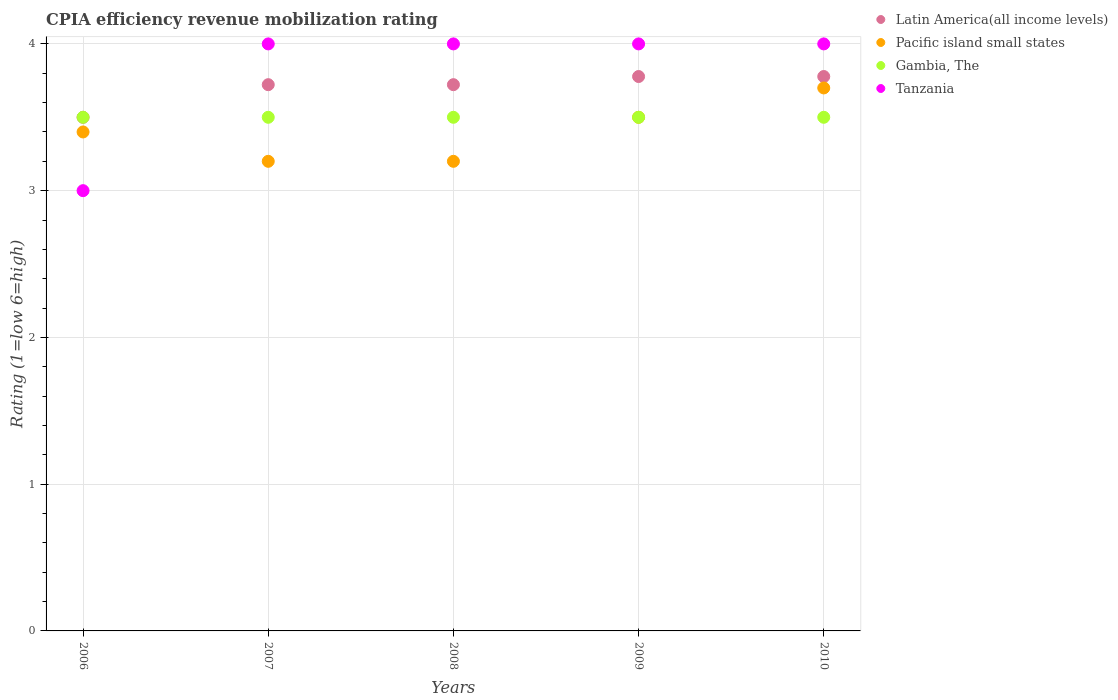How many different coloured dotlines are there?
Your response must be concise. 4. What is the total CPIA rating in Latin America(all income levels) in the graph?
Provide a short and direct response. 18.5. What is the difference between the CPIA rating in Pacific island small states in 2006 and that in 2007?
Your response must be concise. 0.2. What is the average CPIA rating in Pacific island small states per year?
Offer a terse response. 3.4. In the year 2008, what is the difference between the CPIA rating in Tanzania and CPIA rating in Pacific island small states?
Provide a short and direct response. 0.8. What is the ratio of the CPIA rating in Tanzania in 2006 to that in 2007?
Your response must be concise. 0.75. Is the CPIA rating in Gambia, The in 2006 less than that in 2009?
Provide a short and direct response. No. Is the difference between the CPIA rating in Tanzania in 2006 and 2009 greater than the difference between the CPIA rating in Pacific island small states in 2006 and 2009?
Your response must be concise. No. What is the difference between the highest and the second highest CPIA rating in Latin America(all income levels)?
Your response must be concise. 0. What is the difference between the highest and the lowest CPIA rating in Latin America(all income levels)?
Provide a short and direct response. 0.28. Is the sum of the CPIA rating in Latin America(all income levels) in 2008 and 2010 greater than the maximum CPIA rating in Gambia, The across all years?
Your answer should be very brief. Yes. Is it the case that in every year, the sum of the CPIA rating in Pacific island small states and CPIA rating in Latin America(all income levels)  is greater than the sum of CPIA rating in Gambia, The and CPIA rating in Tanzania?
Your answer should be compact. No. Is it the case that in every year, the sum of the CPIA rating in Pacific island small states and CPIA rating in Latin America(all income levels)  is greater than the CPIA rating in Tanzania?
Offer a terse response. Yes. Does the CPIA rating in Tanzania monotonically increase over the years?
Keep it short and to the point. No. Is the CPIA rating in Gambia, The strictly greater than the CPIA rating in Latin America(all income levels) over the years?
Provide a succinct answer. No. What is the difference between two consecutive major ticks on the Y-axis?
Ensure brevity in your answer.  1. Does the graph contain any zero values?
Offer a very short reply. No. Does the graph contain grids?
Your response must be concise. Yes. Where does the legend appear in the graph?
Ensure brevity in your answer.  Top right. How many legend labels are there?
Provide a short and direct response. 4. How are the legend labels stacked?
Provide a short and direct response. Vertical. What is the title of the graph?
Offer a terse response. CPIA efficiency revenue mobilization rating. Does "Jamaica" appear as one of the legend labels in the graph?
Keep it short and to the point. No. What is the label or title of the X-axis?
Your response must be concise. Years. What is the label or title of the Y-axis?
Keep it short and to the point. Rating (1=low 6=high). What is the Rating (1=low 6=high) of Latin America(all income levels) in 2006?
Make the answer very short. 3.5. What is the Rating (1=low 6=high) of Gambia, The in 2006?
Keep it short and to the point. 3.5. What is the Rating (1=low 6=high) in Latin America(all income levels) in 2007?
Offer a very short reply. 3.72. What is the Rating (1=low 6=high) of Pacific island small states in 2007?
Keep it short and to the point. 3.2. What is the Rating (1=low 6=high) of Tanzania in 2007?
Your answer should be very brief. 4. What is the Rating (1=low 6=high) in Latin America(all income levels) in 2008?
Keep it short and to the point. 3.72. What is the Rating (1=low 6=high) of Gambia, The in 2008?
Make the answer very short. 3.5. What is the Rating (1=low 6=high) of Tanzania in 2008?
Give a very brief answer. 4. What is the Rating (1=low 6=high) in Latin America(all income levels) in 2009?
Make the answer very short. 3.78. What is the Rating (1=low 6=high) of Pacific island small states in 2009?
Offer a very short reply. 3.5. What is the Rating (1=low 6=high) in Gambia, The in 2009?
Your response must be concise. 3.5. What is the Rating (1=low 6=high) of Latin America(all income levels) in 2010?
Provide a short and direct response. 3.78. What is the Rating (1=low 6=high) of Pacific island small states in 2010?
Offer a very short reply. 3.7. Across all years, what is the maximum Rating (1=low 6=high) in Latin America(all income levels)?
Provide a short and direct response. 3.78. Across all years, what is the maximum Rating (1=low 6=high) of Gambia, The?
Your answer should be very brief. 3.5. Across all years, what is the minimum Rating (1=low 6=high) in Latin America(all income levels)?
Provide a short and direct response. 3.5. What is the total Rating (1=low 6=high) in Pacific island small states in the graph?
Ensure brevity in your answer.  17. What is the total Rating (1=low 6=high) in Gambia, The in the graph?
Your response must be concise. 17.5. What is the difference between the Rating (1=low 6=high) in Latin America(all income levels) in 2006 and that in 2007?
Give a very brief answer. -0.22. What is the difference between the Rating (1=low 6=high) of Gambia, The in 2006 and that in 2007?
Offer a terse response. 0. What is the difference between the Rating (1=low 6=high) in Tanzania in 2006 and that in 2007?
Your answer should be compact. -1. What is the difference between the Rating (1=low 6=high) of Latin America(all income levels) in 2006 and that in 2008?
Ensure brevity in your answer.  -0.22. What is the difference between the Rating (1=low 6=high) of Pacific island small states in 2006 and that in 2008?
Keep it short and to the point. 0.2. What is the difference between the Rating (1=low 6=high) in Tanzania in 2006 and that in 2008?
Your response must be concise. -1. What is the difference between the Rating (1=low 6=high) in Latin America(all income levels) in 2006 and that in 2009?
Give a very brief answer. -0.28. What is the difference between the Rating (1=low 6=high) of Pacific island small states in 2006 and that in 2009?
Ensure brevity in your answer.  -0.1. What is the difference between the Rating (1=low 6=high) in Gambia, The in 2006 and that in 2009?
Keep it short and to the point. 0. What is the difference between the Rating (1=low 6=high) of Latin America(all income levels) in 2006 and that in 2010?
Your answer should be compact. -0.28. What is the difference between the Rating (1=low 6=high) of Latin America(all income levels) in 2007 and that in 2008?
Give a very brief answer. 0. What is the difference between the Rating (1=low 6=high) of Tanzania in 2007 and that in 2008?
Give a very brief answer. 0. What is the difference between the Rating (1=low 6=high) of Latin America(all income levels) in 2007 and that in 2009?
Make the answer very short. -0.06. What is the difference between the Rating (1=low 6=high) in Pacific island small states in 2007 and that in 2009?
Ensure brevity in your answer.  -0.3. What is the difference between the Rating (1=low 6=high) in Tanzania in 2007 and that in 2009?
Make the answer very short. 0. What is the difference between the Rating (1=low 6=high) of Latin America(all income levels) in 2007 and that in 2010?
Give a very brief answer. -0.06. What is the difference between the Rating (1=low 6=high) of Pacific island small states in 2007 and that in 2010?
Give a very brief answer. -0.5. What is the difference between the Rating (1=low 6=high) of Gambia, The in 2007 and that in 2010?
Offer a very short reply. 0. What is the difference between the Rating (1=low 6=high) in Latin America(all income levels) in 2008 and that in 2009?
Offer a terse response. -0.06. What is the difference between the Rating (1=low 6=high) in Gambia, The in 2008 and that in 2009?
Your answer should be very brief. 0. What is the difference between the Rating (1=low 6=high) in Tanzania in 2008 and that in 2009?
Ensure brevity in your answer.  0. What is the difference between the Rating (1=low 6=high) in Latin America(all income levels) in 2008 and that in 2010?
Keep it short and to the point. -0.06. What is the difference between the Rating (1=low 6=high) in Pacific island small states in 2008 and that in 2010?
Provide a short and direct response. -0.5. What is the difference between the Rating (1=low 6=high) of Latin America(all income levels) in 2009 and that in 2010?
Provide a short and direct response. 0. What is the difference between the Rating (1=low 6=high) of Pacific island small states in 2009 and that in 2010?
Ensure brevity in your answer.  -0.2. What is the difference between the Rating (1=low 6=high) of Gambia, The in 2009 and that in 2010?
Your answer should be very brief. 0. What is the difference between the Rating (1=low 6=high) in Latin America(all income levels) in 2006 and the Rating (1=low 6=high) in Pacific island small states in 2007?
Your answer should be compact. 0.3. What is the difference between the Rating (1=low 6=high) of Pacific island small states in 2006 and the Rating (1=low 6=high) of Tanzania in 2007?
Offer a very short reply. -0.6. What is the difference between the Rating (1=low 6=high) of Gambia, The in 2006 and the Rating (1=low 6=high) of Tanzania in 2007?
Give a very brief answer. -0.5. What is the difference between the Rating (1=low 6=high) in Latin America(all income levels) in 2006 and the Rating (1=low 6=high) in Pacific island small states in 2008?
Give a very brief answer. 0.3. What is the difference between the Rating (1=low 6=high) in Latin America(all income levels) in 2006 and the Rating (1=low 6=high) in Tanzania in 2008?
Make the answer very short. -0.5. What is the difference between the Rating (1=low 6=high) in Pacific island small states in 2006 and the Rating (1=low 6=high) in Tanzania in 2008?
Your answer should be very brief. -0.6. What is the difference between the Rating (1=low 6=high) of Gambia, The in 2006 and the Rating (1=low 6=high) of Tanzania in 2008?
Offer a very short reply. -0.5. What is the difference between the Rating (1=low 6=high) in Pacific island small states in 2006 and the Rating (1=low 6=high) in Gambia, The in 2009?
Keep it short and to the point. -0.1. What is the difference between the Rating (1=low 6=high) of Gambia, The in 2006 and the Rating (1=low 6=high) of Tanzania in 2009?
Ensure brevity in your answer.  -0.5. What is the difference between the Rating (1=low 6=high) in Latin America(all income levels) in 2006 and the Rating (1=low 6=high) in Pacific island small states in 2010?
Ensure brevity in your answer.  -0.2. What is the difference between the Rating (1=low 6=high) in Latin America(all income levels) in 2006 and the Rating (1=low 6=high) in Gambia, The in 2010?
Your answer should be compact. 0. What is the difference between the Rating (1=low 6=high) of Latin America(all income levels) in 2007 and the Rating (1=low 6=high) of Pacific island small states in 2008?
Offer a very short reply. 0.52. What is the difference between the Rating (1=low 6=high) of Latin America(all income levels) in 2007 and the Rating (1=low 6=high) of Gambia, The in 2008?
Offer a terse response. 0.22. What is the difference between the Rating (1=low 6=high) of Latin America(all income levels) in 2007 and the Rating (1=low 6=high) of Tanzania in 2008?
Your answer should be very brief. -0.28. What is the difference between the Rating (1=low 6=high) of Latin America(all income levels) in 2007 and the Rating (1=low 6=high) of Pacific island small states in 2009?
Your answer should be very brief. 0.22. What is the difference between the Rating (1=low 6=high) in Latin America(all income levels) in 2007 and the Rating (1=low 6=high) in Gambia, The in 2009?
Provide a succinct answer. 0.22. What is the difference between the Rating (1=low 6=high) of Latin America(all income levels) in 2007 and the Rating (1=low 6=high) of Tanzania in 2009?
Offer a very short reply. -0.28. What is the difference between the Rating (1=low 6=high) in Pacific island small states in 2007 and the Rating (1=low 6=high) in Gambia, The in 2009?
Ensure brevity in your answer.  -0.3. What is the difference between the Rating (1=low 6=high) in Pacific island small states in 2007 and the Rating (1=low 6=high) in Tanzania in 2009?
Keep it short and to the point. -0.8. What is the difference between the Rating (1=low 6=high) in Latin America(all income levels) in 2007 and the Rating (1=low 6=high) in Pacific island small states in 2010?
Make the answer very short. 0.02. What is the difference between the Rating (1=low 6=high) in Latin America(all income levels) in 2007 and the Rating (1=low 6=high) in Gambia, The in 2010?
Your response must be concise. 0.22. What is the difference between the Rating (1=low 6=high) of Latin America(all income levels) in 2007 and the Rating (1=low 6=high) of Tanzania in 2010?
Ensure brevity in your answer.  -0.28. What is the difference between the Rating (1=low 6=high) in Pacific island small states in 2007 and the Rating (1=low 6=high) in Gambia, The in 2010?
Offer a terse response. -0.3. What is the difference between the Rating (1=low 6=high) of Pacific island small states in 2007 and the Rating (1=low 6=high) of Tanzania in 2010?
Offer a terse response. -0.8. What is the difference between the Rating (1=low 6=high) of Latin America(all income levels) in 2008 and the Rating (1=low 6=high) of Pacific island small states in 2009?
Your answer should be very brief. 0.22. What is the difference between the Rating (1=low 6=high) of Latin America(all income levels) in 2008 and the Rating (1=low 6=high) of Gambia, The in 2009?
Offer a terse response. 0.22. What is the difference between the Rating (1=low 6=high) in Latin America(all income levels) in 2008 and the Rating (1=low 6=high) in Tanzania in 2009?
Make the answer very short. -0.28. What is the difference between the Rating (1=low 6=high) in Pacific island small states in 2008 and the Rating (1=low 6=high) in Gambia, The in 2009?
Offer a terse response. -0.3. What is the difference between the Rating (1=low 6=high) in Pacific island small states in 2008 and the Rating (1=low 6=high) in Tanzania in 2009?
Make the answer very short. -0.8. What is the difference between the Rating (1=low 6=high) in Gambia, The in 2008 and the Rating (1=low 6=high) in Tanzania in 2009?
Your response must be concise. -0.5. What is the difference between the Rating (1=low 6=high) in Latin America(all income levels) in 2008 and the Rating (1=low 6=high) in Pacific island small states in 2010?
Make the answer very short. 0.02. What is the difference between the Rating (1=low 6=high) in Latin America(all income levels) in 2008 and the Rating (1=low 6=high) in Gambia, The in 2010?
Give a very brief answer. 0.22. What is the difference between the Rating (1=low 6=high) in Latin America(all income levels) in 2008 and the Rating (1=low 6=high) in Tanzania in 2010?
Provide a succinct answer. -0.28. What is the difference between the Rating (1=low 6=high) in Pacific island small states in 2008 and the Rating (1=low 6=high) in Gambia, The in 2010?
Ensure brevity in your answer.  -0.3. What is the difference between the Rating (1=low 6=high) of Latin America(all income levels) in 2009 and the Rating (1=low 6=high) of Pacific island small states in 2010?
Provide a short and direct response. 0.08. What is the difference between the Rating (1=low 6=high) in Latin America(all income levels) in 2009 and the Rating (1=low 6=high) in Gambia, The in 2010?
Make the answer very short. 0.28. What is the difference between the Rating (1=low 6=high) in Latin America(all income levels) in 2009 and the Rating (1=low 6=high) in Tanzania in 2010?
Keep it short and to the point. -0.22. What is the average Rating (1=low 6=high) of Pacific island small states per year?
Provide a succinct answer. 3.4. What is the average Rating (1=low 6=high) in Gambia, The per year?
Offer a very short reply. 3.5. What is the average Rating (1=low 6=high) in Tanzania per year?
Your answer should be very brief. 3.8. In the year 2006, what is the difference between the Rating (1=low 6=high) in Latin America(all income levels) and Rating (1=low 6=high) in Gambia, The?
Your answer should be compact. 0. In the year 2006, what is the difference between the Rating (1=low 6=high) of Latin America(all income levels) and Rating (1=low 6=high) of Tanzania?
Offer a very short reply. 0.5. In the year 2006, what is the difference between the Rating (1=low 6=high) of Pacific island small states and Rating (1=low 6=high) of Tanzania?
Provide a short and direct response. 0.4. In the year 2007, what is the difference between the Rating (1=low 6=high) in Latin America(all income levels) and Rating (1=low 6=high) in Pacific island small states?
Provide a short and direct response. 0.52. In the year 2007, what is the difference between the Rating (1=low 6=high) in Latin America(all income levels) and Rating (1=low 6=high) in Gambia, The?
Ensure brevity in your answer.  0.22. In the year 2007, what is the difference between the Rating (1=low 6=high) in Latin America(all income levels) and Rating (1=low 6=high) in Tanzania?
Your answer should be very brief. -0.28. In the year 2007, what is the difference between the Rating (1=low 6=high) of Pacific island small states and Rating (1=low 6=high) of Gambia, The?
Ensure brevity in your answer.  -0.3. In the year 2007, what is the difference between the Rating (1=low 6=high) in Pacific island small states and Rating (1=low 6=high) in Tanzania?
Offer a very short reply. -0.8. In the year 2007, what is the difference between the Rating (1=low 6=high) of Gambia, The and Rating (1=low 6=high) of Tanzania?
Provide a succinct answer. -0.5. In the year 2008, what is the difference between the Rating (1=low 6=high) in Latin America(all income levels) and Rating (1=low 6=high) in Pacific island small states?
Make the answer very short. 0.52. In the year 2008, what is the difference between the Rating (1=low 6=high) in Latin America(all income levels) and Rating (1=low 6=high) in Gambia, The?
Provide a succinct answer. 0.22. In the year 2008, what is the difference between the Rating (1=low 6=high) of Latin America(all income levels) and Rating (1=low 6=high) of Tanzania?
Ensure brevity in your answer.  -0.28. In the year 2008, what is the difference between the Rating (1=low 6=high) of Pacific island small states and Rating (1=low 6=high) of Tanzania?
Your response must be concise. -0.8. In the year 2009, what is the difference between the Rating (1=low 6=high) of Latin America(all income levels) and Rating (1=low 6=high) of Pacific island small states?
Offer a terse response. 0.28. In the year 2009, what is the difference between the Rating (1=low 6=high) of Latin America(all income levels) and Rating (1=low 6=high) of Gambia, The?
Your answer should be compact. 0.28. In the year 2009, what is the difference between the Rating (1=low 6=high) in Latin America(all income levels) and Rating (1=low 6=high) in Tanzania?
Give a very brief answer. -0.22. In the year 2009, what is the difference between the Rating (1=low 6=high) in Pacific island small states and Rating (1=low 6=high) in Gambia, The?
Offer a very short reply. 0. In the year 2009, what is the difference between the Rating (1=low 6=high) in Pacific island small states and Rating (1=low 6=high) in Tanzania?
Make the answer very short. -0.5. In the year 2010, what is the difference between the Rating (1=low 6=high) of Latin America(all income levels) and Rating (1=low 6=high) of Pacific island small states?
Provide a short and direct response. 0.08. In the year 2010, what is the difference between the Rating (1=low 6=high) of Latin America(all income levels) and Rating (1=low 6=high) of Gambia, The?
Keep it short and to the point. 0.28. In the year 2010, what is the difference between the Rating (1=low 6=high) of Latin America(all income levels) and Rating (1=low 6=high) of Tanzania?
Ensure brevity in your answer.  -0.22. In the year 2010, what is the difference between the Rating (1=low 6=high) in Pacific island small states and Rating (1=low 6=high) in Gambia, The?
Your answer should be very brief. 0.2. In the year 2010, what is the difference between the Rating (1=low 6=high) of Gambia, The and Rating (1=low 6=high) of Tanzania?
Offer a very short reply. -0.5. What is the ratio of the Rating (1=low 6=high) of Latin America(all income levels) in 2006 to that in 2007?
Your response must be concise. 0.94. What is the ratio of the Rating (1=low 6=high) in Pacific island small states in 2006 to that in 2007?
Make the answer very short. 1.06. What is the ratio of the Rating (1=low 6=high) in Gambia, The in 2006 to that in 2007?
Your response must be concise. 1. What is the ratio of the Rating (1=low 6=high) of Tanzania in 2006 to that in 2007?
Give a very brief answer. 0.75. What is the ratio of the Rating (1=low 6=high) of Latin America(all income levels) in 2006 to that in 2008?
Offer a very short reply. 0.94. What is the ratio of the Rating (1=low 6=high) in Latin America(all income levels) in 2006 to that in 2009?
Offer a terse response. 0.93. What is the ratio of the Rating (1=low 6=high) of Pacific island small states in 2006 to that in 2009?
Ensure brevity in your answer.  0.97. What is the ratio of the Rating (1=low 6=high) in Gambia, The in 2006 to that in 2009?
Provide a short and direct response. 1. What is the ratio of the Rating (1=low 6=high) of Tanzania in 2006 to that in 2009?
Offer a terse response. 0.75. What is the ratio of the Rating (1=low 6=high) in Latin America(all income levels) in 2006 to that in 2010?
Keep it short and to the point. 0.93. What is the ratio of the Rating (1=low 6=high) of Pacific island small states in 2006 to that in 2010?
Provide a succinct answer. 0.92. What is the ratio of the Rating (1=low 6=high) of Pacific island small states in 2007 to that in 2008?
Provide a short and direct response. 1. What is the ratio of the Rating (1=low 6=high) of Tanzania in 2007 to that in 2008?
Offer a very short reply. 1. What is the ratio of the Rating (1=low 6=high) in Pacific island small states in 2007 to that in 2009?
Make the answer very short. 0.91. What is the ratio of the Rating (1=low 6=high) in Gambia, The in 2007 to that in 2009?
Your response must be concise. 1. What is the ratio of the Rating (1=low 6=high) in Latin America(all income levels) in 2007 to that in 2010?
Make the answer very short. 0.99. What is the ratio of the Rating (1=low 6=high) in Pacific island small states in 2007 to that in 2010?
Give a very brief answer. 0.86. What is the ratio of the Rating (1=low 6=high) of Gambia, The in 2007 to that in 2010?
Provide a short and direct response. 1. What is the ratio of the Rating (1=low 6=high) of Tanzania in 2007 to that in 2010?
Your answer should be very brief. 1. What is the ratio of the Rating (1=low 6=high) of Latin America(all income levels) in 2008 to that in 2009?
Your answer should be very brief. 0.99. What is the ratio of the Rating (1=low 6=high) of Pacific island small states in 2008 to that in 2009?
Keep it short and to the point. 0.91. What is the ratio of the Rating (1=low 6=high) of Gambia, The in 2008 to that in 2009?
Your answer should be very brief. 1. What is the ratio of the Rating (1=low 6=high) in Pacific island small states in 2008 to that in 2010?
Your answer should be very brief. 0.86. What is the ratio of the Rating (1=low 6=high) of Pacific island small states in 2009 to that in 2010?
Provide a succinct answer. 0.95. What is the difference between the highest and the second highest Rating (1=low 6=high) in Gambia, The?
Provide a short and direct response. 0. What is the difference between the highest and the lowest Rating (1=low 6=high) in Latin America(all income levels)?
Ensure brevity in your answer.  0.28. What is the difference between the highest and the lowest Rating (1=low 6=high) in Gambia, The?
Offer a very short reply. 0. 